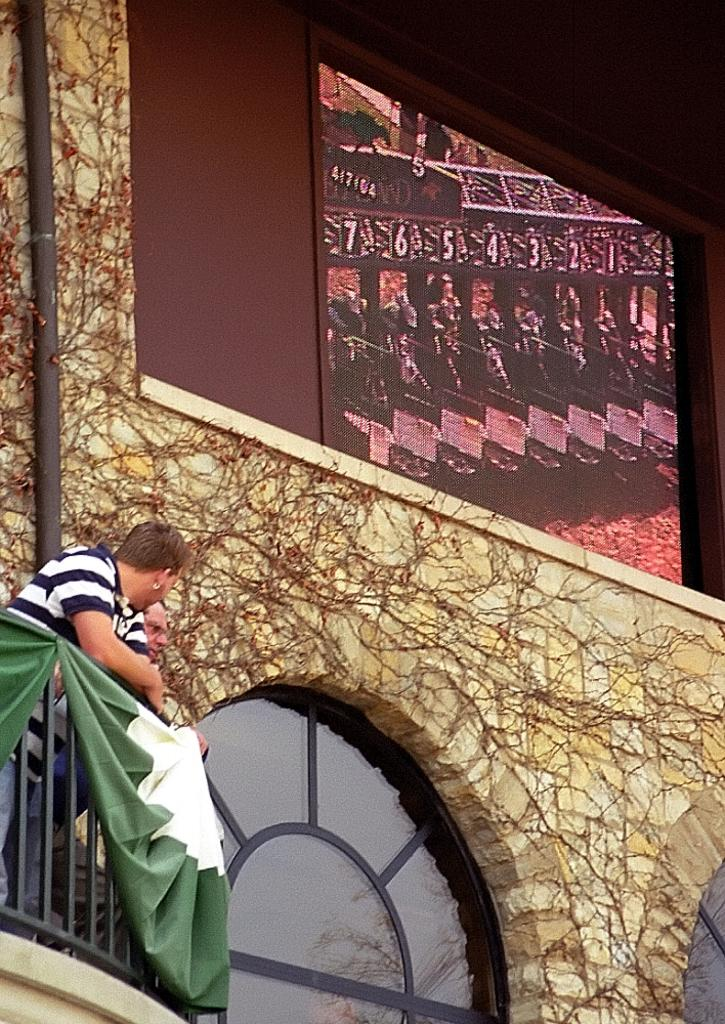How many people are in the image? There are two people in the image. What can be seen in the image besides the people? There is a pole and a wall in the image, as well as some objects. What news is being discussed by the people in the image? There is no indication of any news being discussed in the image; it only shows two people, a pole, a wall, and some objects. 